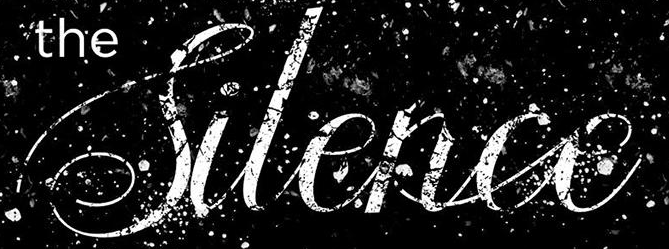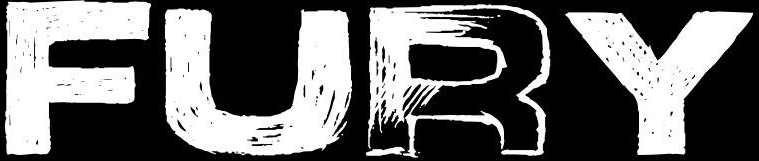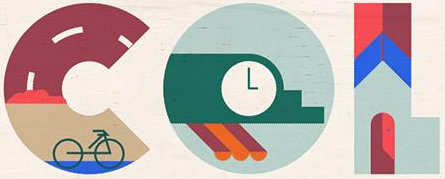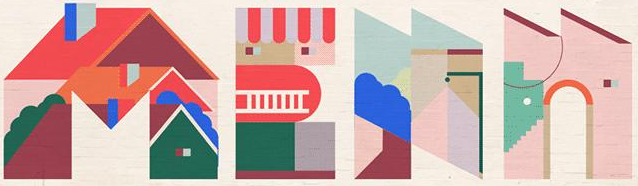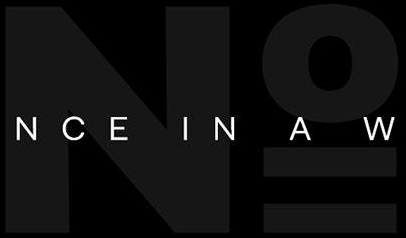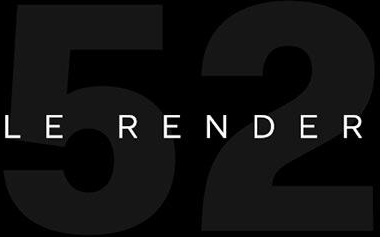Read the text from these images in sequence, separated by a semicolon. Silence; FURY; COL; MEAN; No; 52 